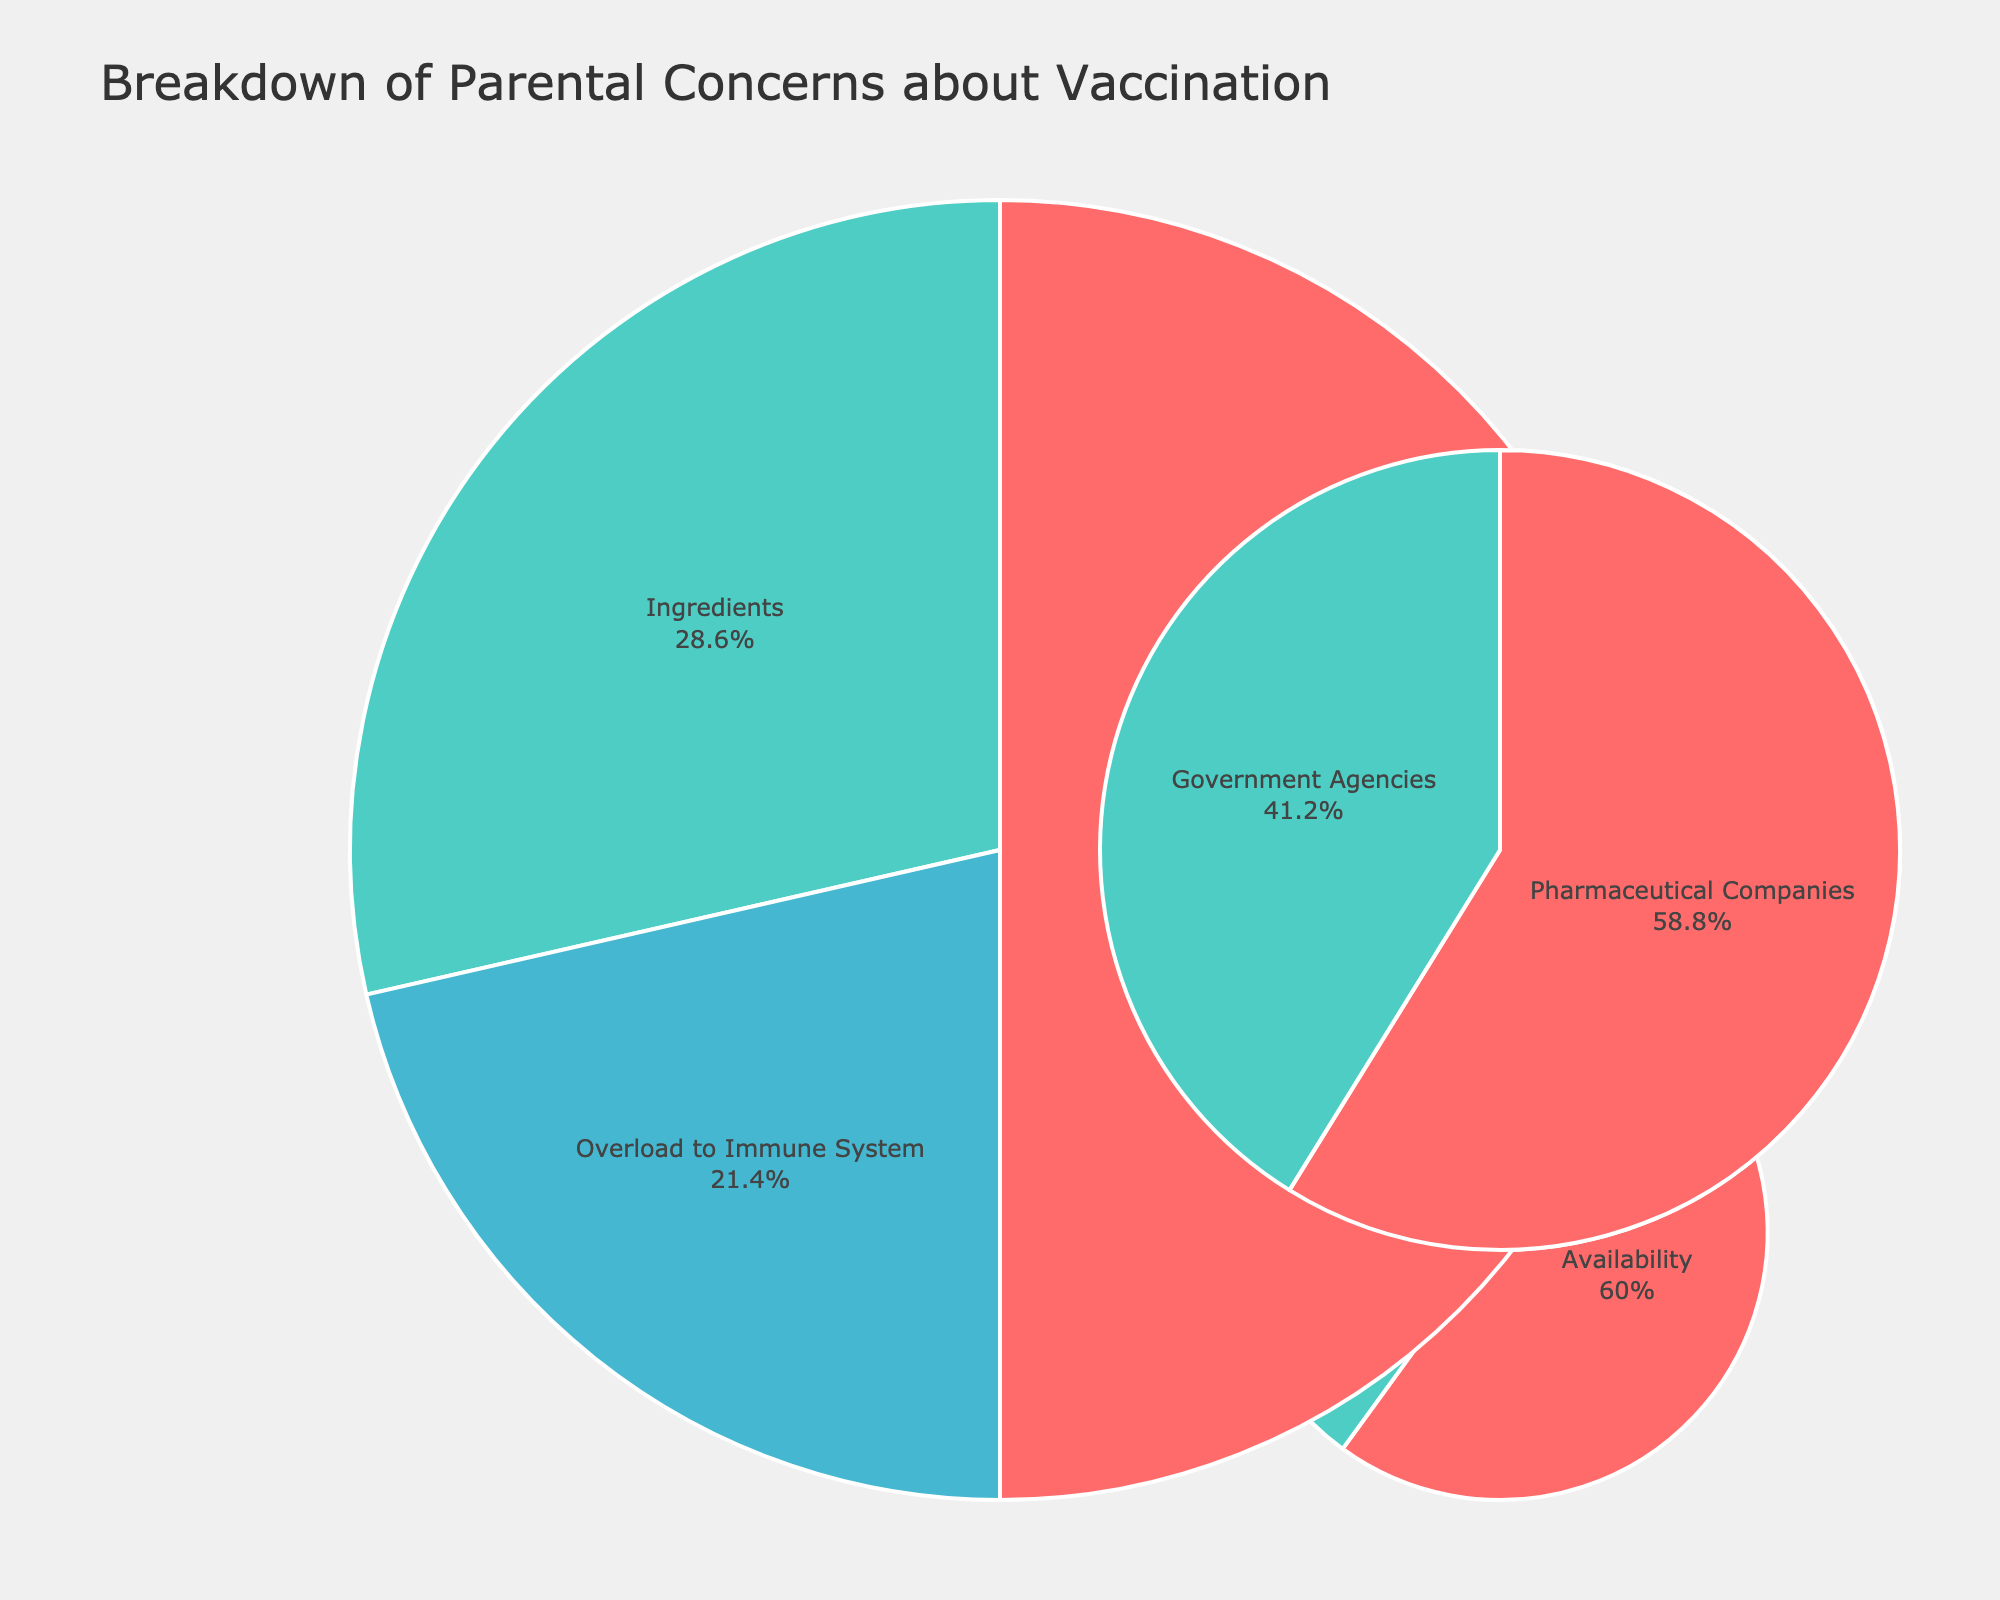what is the largest concern under the Safety category? According to the Safety pie chart, the largest concern as indicated by the highest percentage is 'Side Effects' at 35%
Answer: Side Effects How much higher is the percentage of concerns about Side Effects compared to Ingredients in the Safety category? In the Safety category, Side Effects are at 35% and Ingredients are at 20%. Subtracting these gives 35% - 20% = 15%
Answer: 15% What percentage of concerns fall under the Trust category? From the Trust pie chart, the sum of percentages for Pharmaceutical Companies and Government Agencies is 10% + 7% = 17%
Answer: 17% Which concern is least represented in the figure? The concern 'Cost' under the Access category has the lowest percentage at 2%
Answer: Cost How many categories are represented in the overall chart? The figure shows pie charts for four distinct categories: Safety, Efficacy, Necessity, and Trust
Answer: 4 Rank the categories by the total percentage of concerns they represent. Summing up each category: Safety (35% + 20% + 15% = 70%), Efficacy (12% + 8% = 20%), Necessity (5% + 3% = 8%), Trust (10% + 7% = 17%). Ranking them from highest to lowest: Safety, Efficacy, Trust, Necessity
Answer: Safety, Efficacy, Trust, Necessity What is the combined percentage of concerns that relate to the effectiveness of vaccines? The Efficacy category addresses concerns about Effectiveness (12%) and Long-term Protection (8%). Adding these together gives 12% + 8% = 20%
Answer: 20% How does the concern about Disease Rarity compare to Natural Immunity in the Necessity category? In the Necessity pie chart, Disease Rarity is at 5% and Natural Immunity is at 3%, indicating Disease Rarity is 2% higher
Answer: Disease Rarity is 2% higher In terms of total representation, which is the least concerning category? Summing up each category’s total percentages: Safety (70%), Efficacy (20%), Necessity (8%), Trust (17%), Access (3% + 2% = 5%). The least concerning category is Access at 5%
Answer: Access What is the second most common concern under the Safety category? Within the Safety pie chart, the second most common concern after Side Effects (35%) is Ingredients at 20%
Answer: Ingredients 